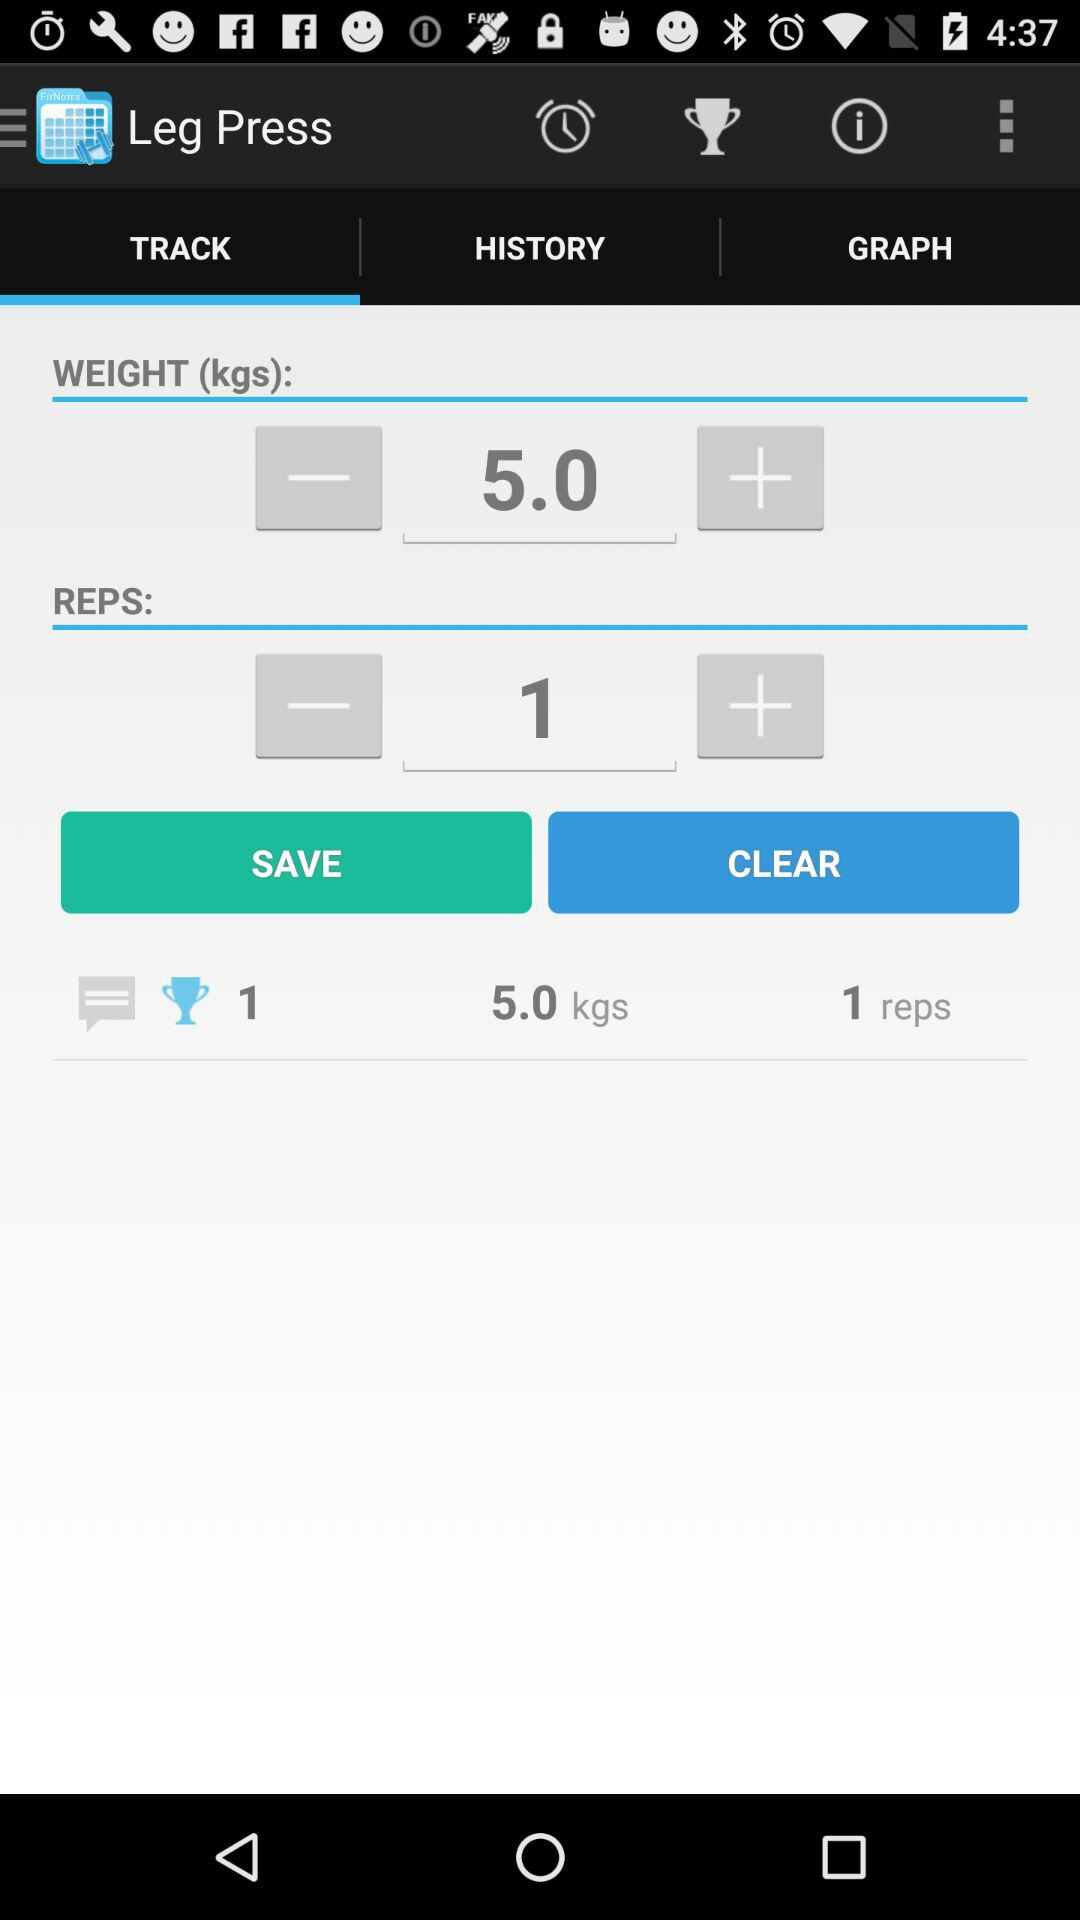What are the reps? The number of reps is 1. 